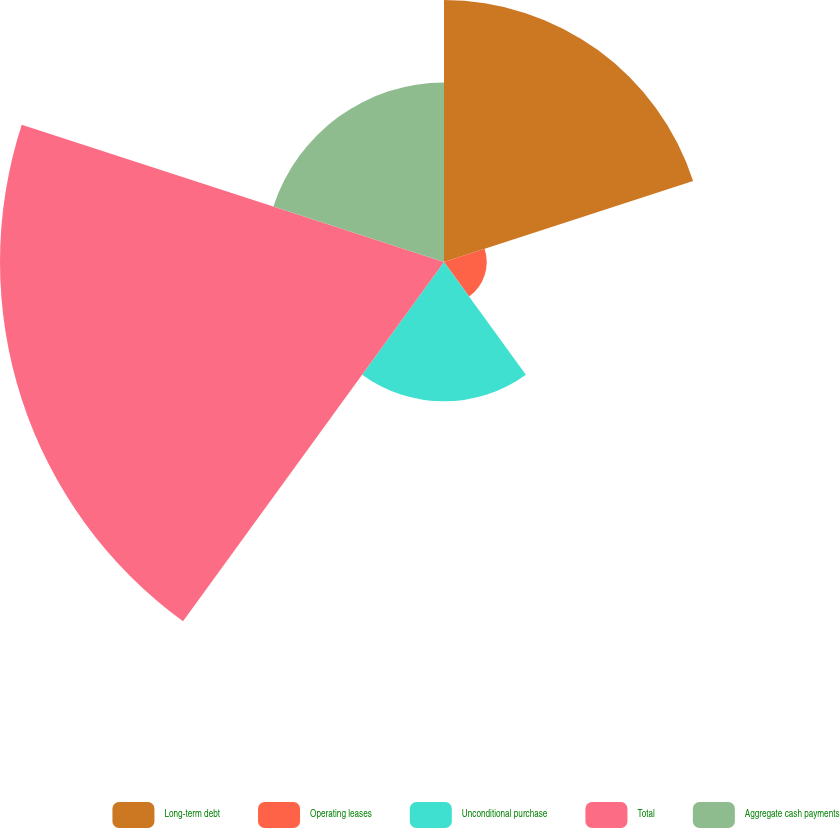Convert chart to OTSL. <chart><loc_0><loc_0><loc_500><loc_500><pie_chart><fcel>Long-term debt<fcel>Operating leases<fcel>Unconditional purchase<fcel>Total<fcel>Aggregate cash payments<nl><fcel>24.54%<fcel>4.0%<fcel>13.05%<fcel>41.6%<fcel>16.81%<nl></chart> 